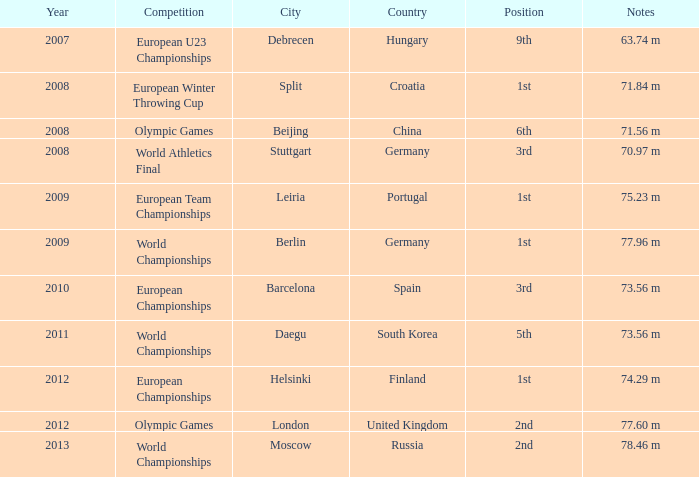What were the notes in 2011? 73.56 m. 